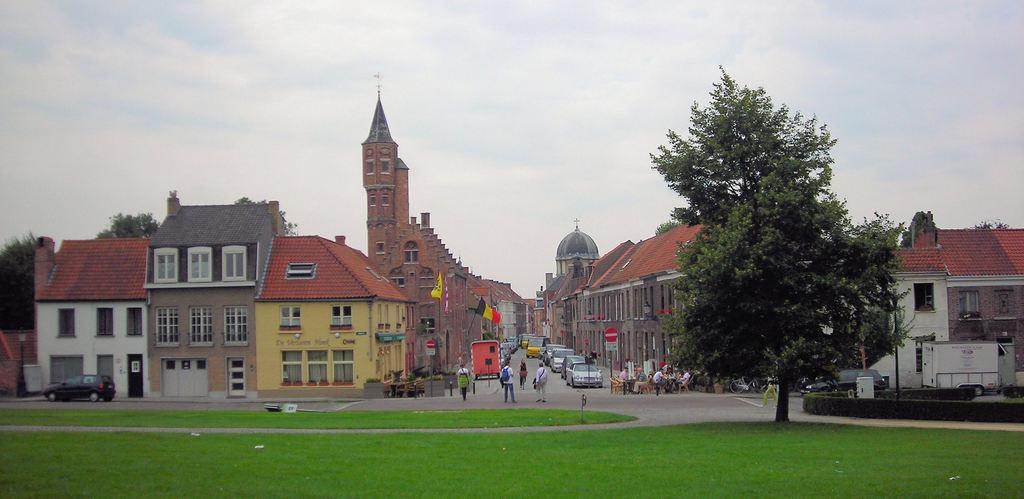What type of landscape is depicted in the image? There is a grassland in the image. What natural element can be seen in the image? There is a tree in the image. What can be seen in the background of the image? There is a road, cars, people, houses, and the sky visible in the image. What company is responsible for the attack on the grassland in the image? There is no attack or company mentioned in the image; it depicts a grassland with a tree, a road, cars, people, houses, and the sky. 